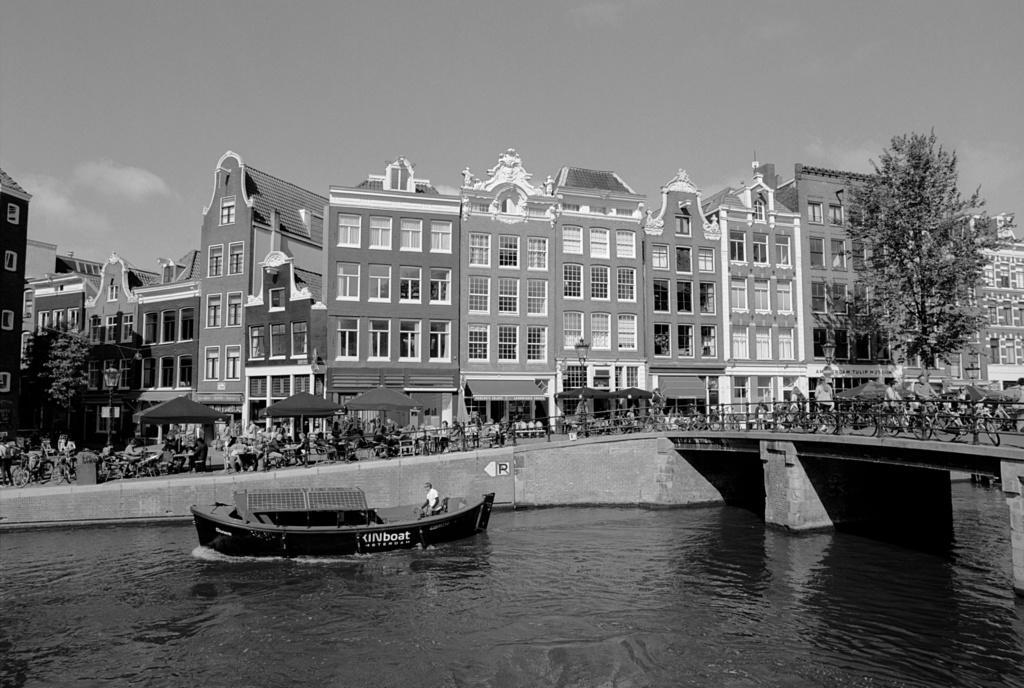Can you describe this image briefly? These are buildings and trees, this is boat in the water, this is sky. 